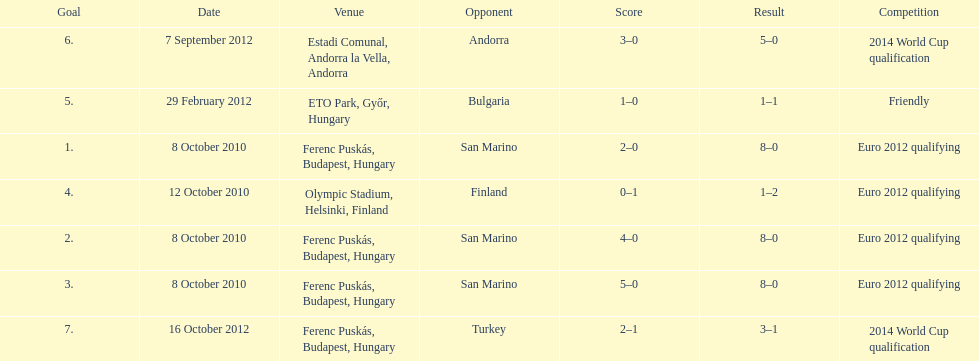What is the number of goals ádám szalai made against san marino in 2010? 3. 